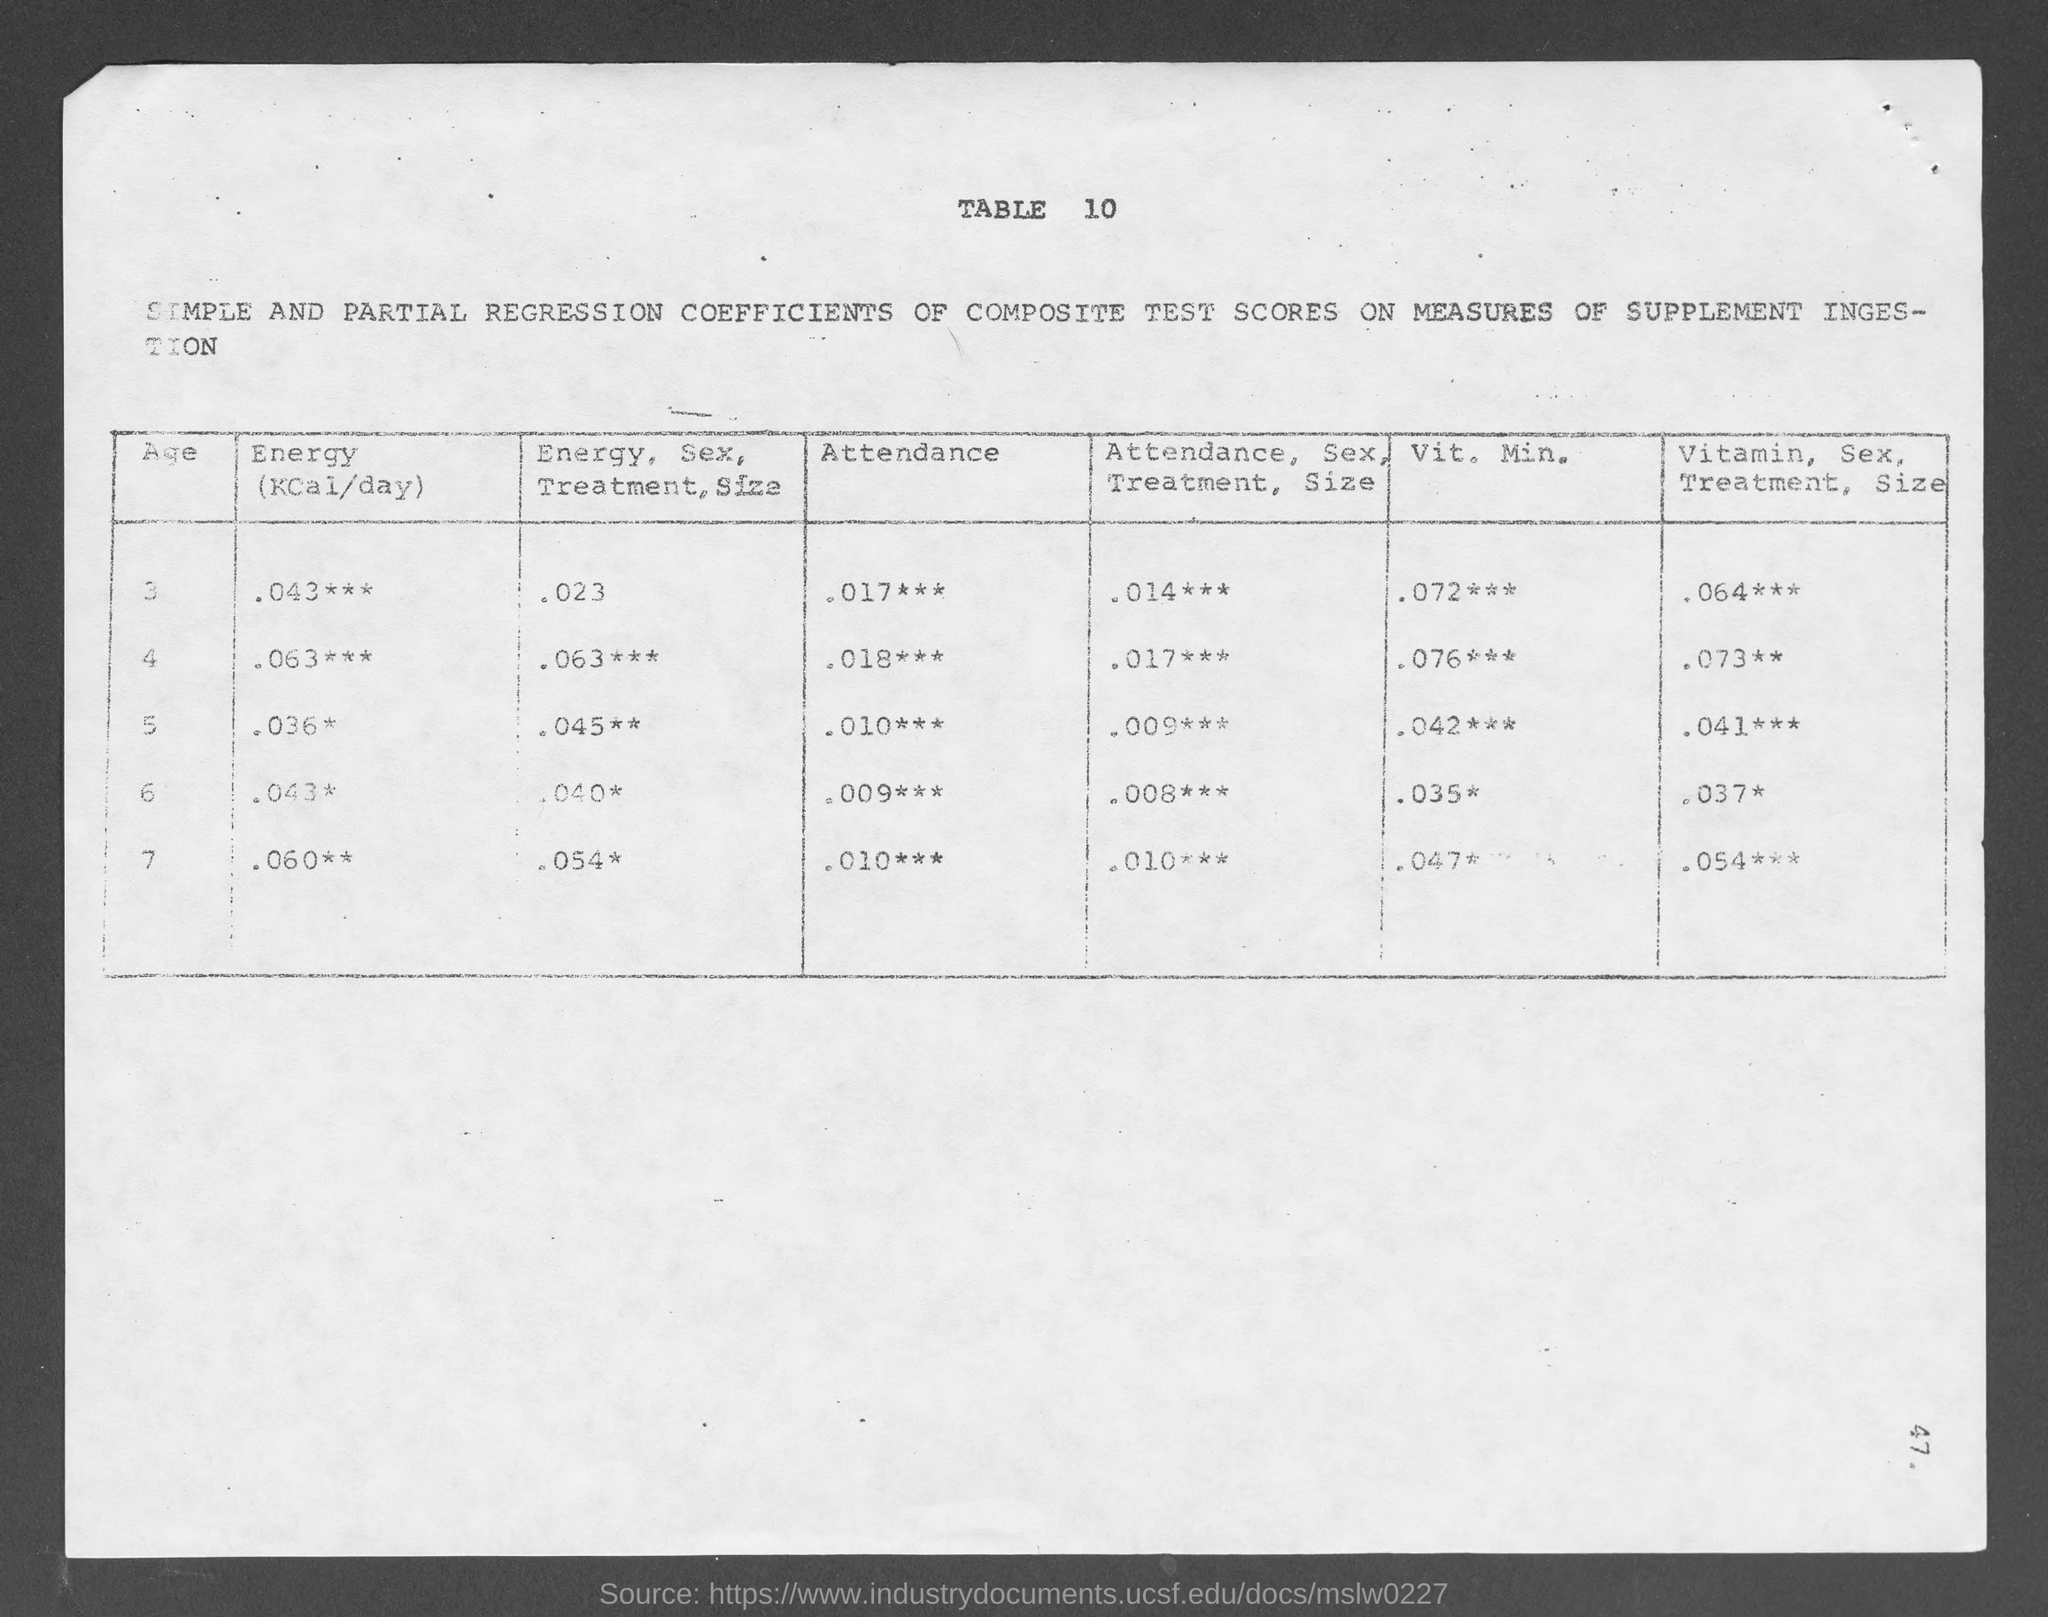what is the table no.? The table is numbered Table 10 as indicated at the top of the document. 